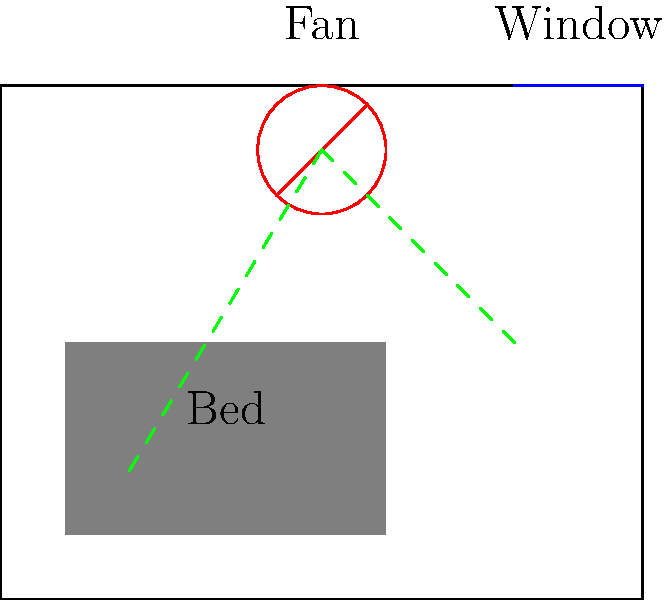In a bedroom setup for a nurse's daytime sleep, a ceiling fan is used for air circulation. The fan is positioned off-center, closer to the window. What fluid dynamics principle explains why this arrangement might be more effective for ventilation while minimizing noise compared to a central position? How would you adjust the fan speed to optimize air flow without increasing noise levels? To answer this question, we need to consider several fluid dynamics principles:

1. Bernoulli's principle: As air moves faster, its pressure decreases. This principle is crucial for understanding air movement in the room.

2. Boundary layer effects: Air moving along surfaces (walls, ceiling) experiences friction, creating a thin layer of slower-moving air.

3. Coanda effect: A fluid jet tends to follow the nearby surface, which can help distribute air more effectively in the room.

4. Turbulence: Faster air movement creates more turbulence, which increases noise levels.

Given these principles, we can explain the effectiveness of the off-center fan position:

1. Proximity to the window: The fan's position near the window allows it to more effectively circulate fresh air from outside, creating a natural flow path.

2. Coanda effect utilization: The fan's proximity to the wall and ceiling allows the Coanda effect to come into play, helping distribute air along these surfaces more efficiently.

3. Reduced direct air impact: The off-center position reduces direct air flow onto the bed, which could be disruptive to sleep.

To optimize air flow without increasing noise:

1. Use a lower fan speed: This reduces turbulence and noise while still maintaining circulation.

2. Adjust blade pitch: A larger blade pitch can move more air at lower speeds, maintaining efficiency while reducing noise.

3. Utilize natural convection: The temperature difference between the window and room can create natural air movement, which the fan can enhance without significant speed increases.

The optimal solution involves finding the right balance between fan speed, blade pitch, and natural air circulation to achieve effective ventilation with minimal noise.
Answer: Off-center positioning utilizes Coanda effect and natural convection; optimize with lower speed and larger blade pitch. 